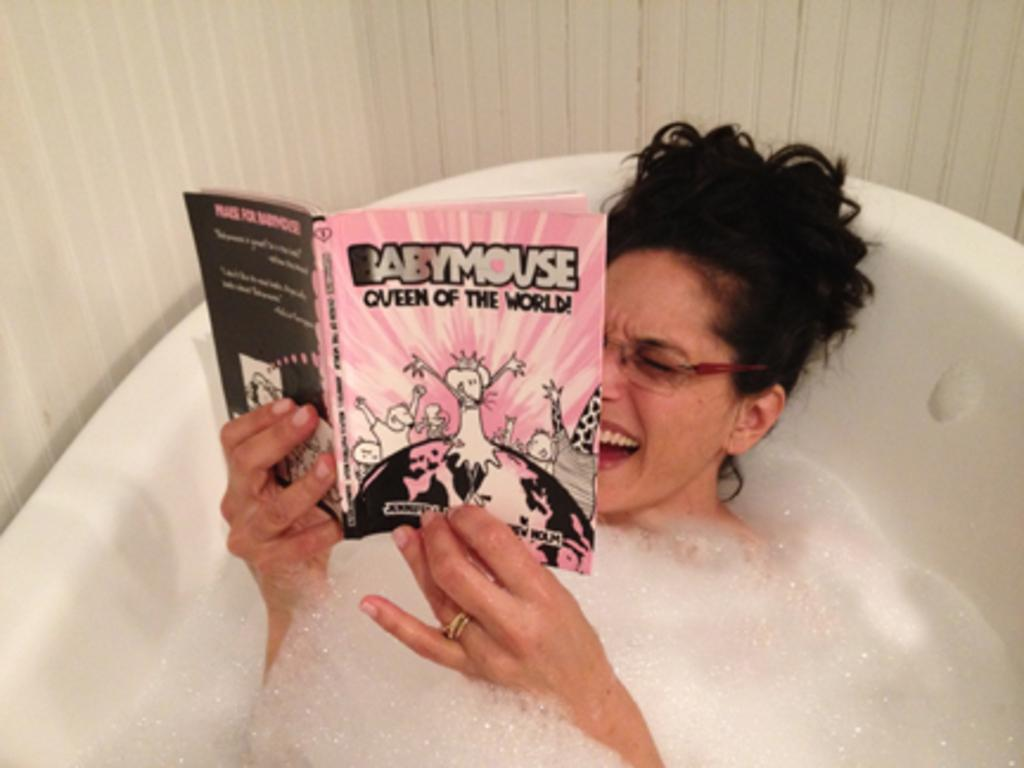Who is the main subject in the image? There is a woman in the image. What is the woman doing in the image? The woman is reading a book. Where is the woman located in the image? The woman is lying in a tub. What can be seen in the background of the image? There is a wall in the image. What type of milk is the woman drinking in the image? There is no milk present in the image; the woman is reading a book while lying in a tub. 